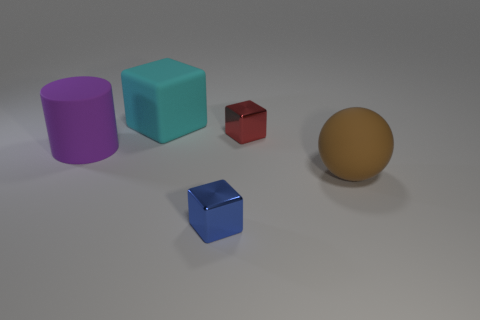Which of the objects appears to be in the foreground? The small blue cube appears to be placed in the foreground, given that it is positioned lower in the image field and its size relative to the other objects makes it stand out as closer to the viewer. How does the lighting in the image affect the way we perceive these objects? The soft and diffused lighting in the image creates gentle shadows that contribute to the perception of depth, emphasizing the three-dimensionality of the objects. It also enhances the texture and color of the objects, adding to the visual interest of the scene. 